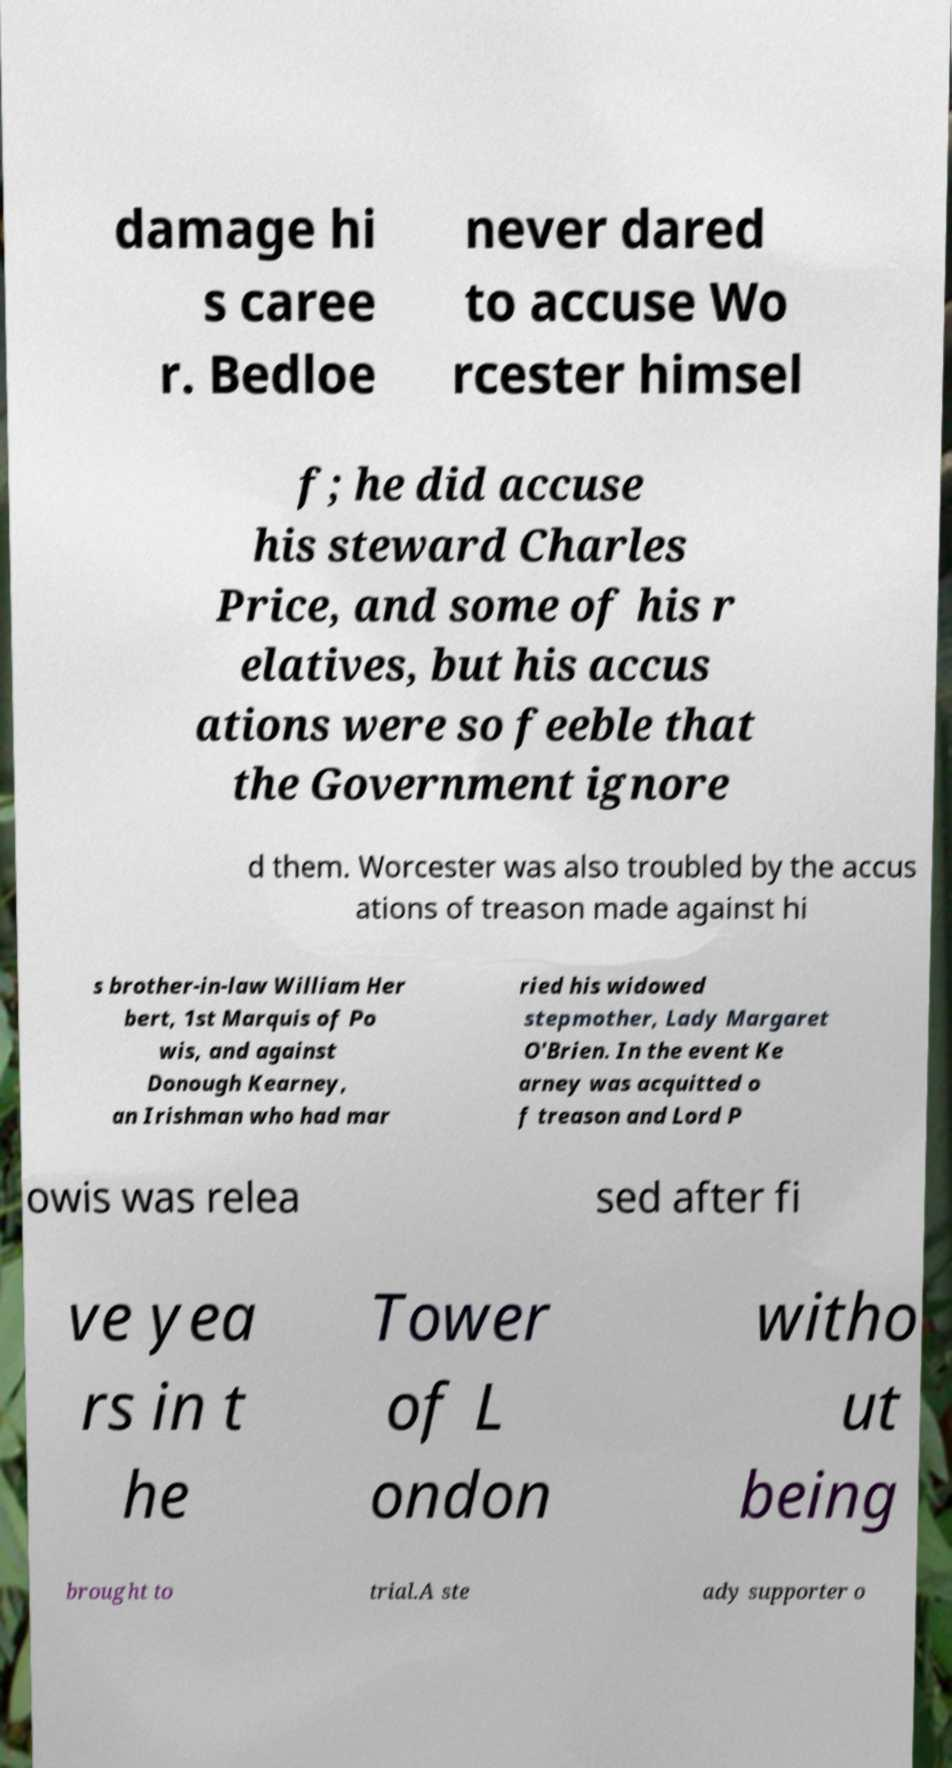Can you accurately transcribe the text from the provided image for me? damage hi s caree r. Bedloe never dared to accuse Wo rcester himsel f; he did accuse his steward Charles Price, and some of his r elatives, but his accus ations were so feeble that the Government ignore d them. Worcester was also troubled by the accus ations of treason made against hi s brother-in-law William Her bert, 1st Marquis of Po wis, and against Donough Kearney, an Irishman who had mar ried his widowed stepmother, Lady Margaret O'Brien. In the event Ke arney was acquitted o f treason and Lord P owis was relea sed after fi ve yea rs in t he Tower of L ondon witho ut being brought to trial.A ste ady supporter o 